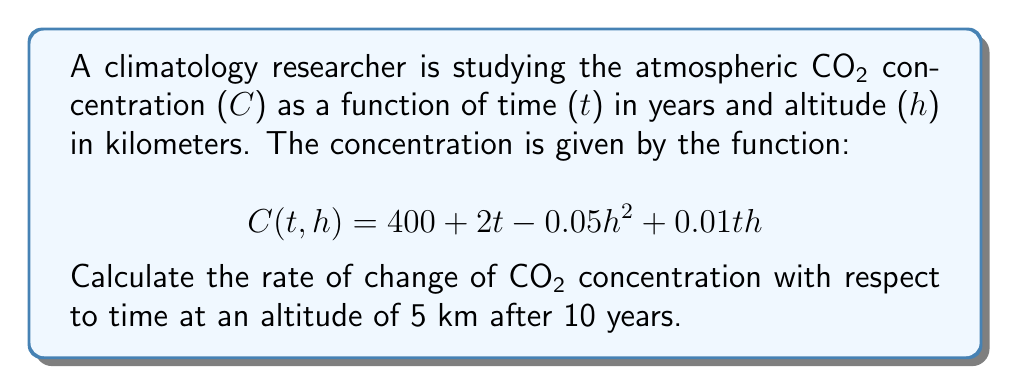Could you help me with this problem? To solve this problem, we need to use partial derivatives. We're looking for the rate of change of CO2 concentration with respect to time, which is represented by the partial derivative $\frac{\partial C}{\partial t}$.

Step 1: Calculate the partial derivative $\frac{\partial C}{\partial t}$
$$\frac{\partial C}{\partial t} = 2 + 0.01h$$

Step 2: Substitute the given values
We're asked to calculate this at an altitude of 5 km after 10 years. The time (t) doesn't appear in our partial derivative, so we only need to substitute h = 5.

$$\frac{\partial C}{\partial t} = 2 + 0.01(5) = 2 + 0.05 = 2.05$$

Step 3: Interpret the result
The rate of change of CO2 concentration with respect to time at an altitude of 5 km is 2.05 ppm/year. This means that at this altitude, the CO2 concentration is increasing by 2.05 parts per million each year.
Answer: $2.05$ ppm/year 